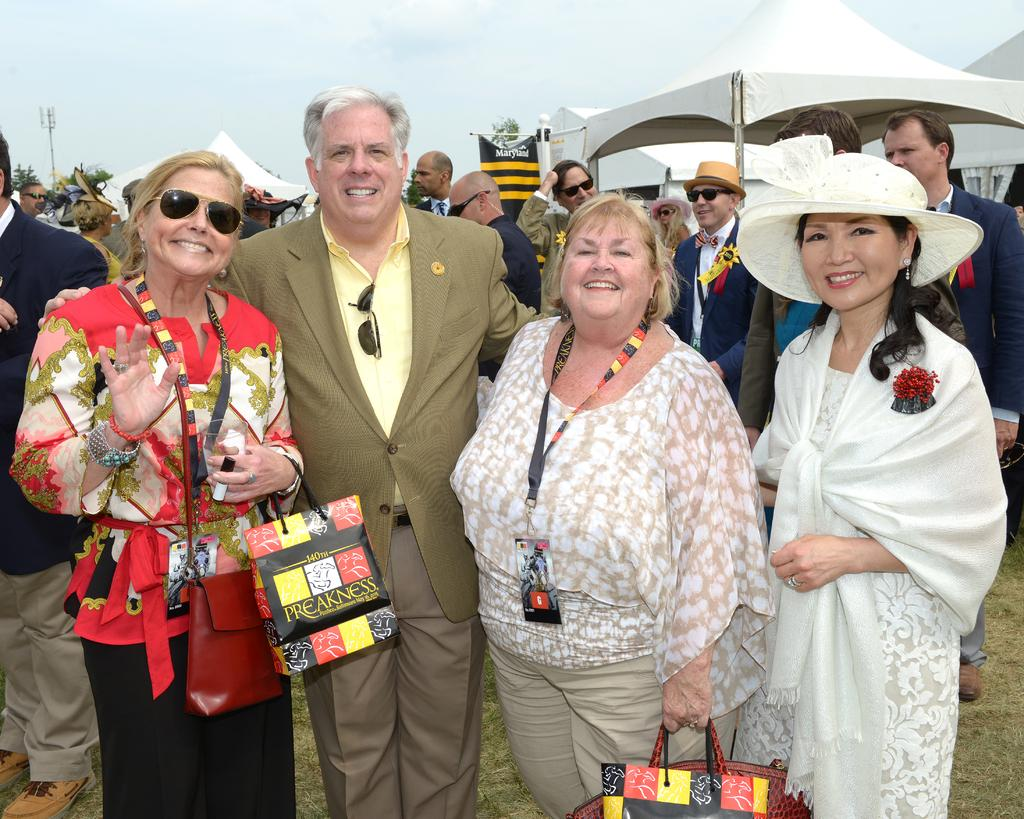What is the main subject of the image? The main subject of the image is a group of people. What are the people in the image doing? The people are smiling in the image. What can be seen in the background of the image? There are tents and trees in the background of the image. What is visible at the top of the image? The sky is visible at the top of the image. How many people are crying in the image? There are no people crying in the image; the people are smiling. Can you describe the romantic interaction between the people in the image? There is no romantic interaction depicted in the image; the people are simply smiling. 